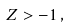Convert formula to latex. <formula><loc_0><loc_0><loc_500><loc_500>Z > - 1 \, ,</formula> 